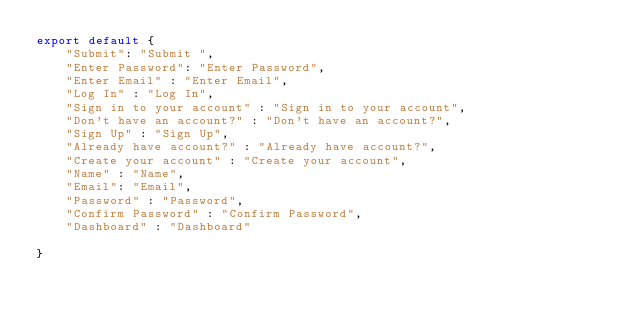Convert code to text. <code><loc_0><loc_0><loc_500><loc_500><_JavaScript_>export default {
    "Submit": "Submit ",
    "Enter Password": "Enter Password",
    "Enter Email" : "Enter Email",
    "Log In" : "Log In",
    "Sign in to your account" : "Sign in to your account",
    "Don't have an account?" : "Don't have an account?",
    "Sign Up" : "Sign Up",
    "Already have account?" : "Already have account?",
    "Create your account" : "Create your account",
    "Name" : "Name",
    "Email": "Email",
    "Password" : "Password",
    "Confirm Password" : "Confirm Password",
    "Dashboard" : "Dashboard"

}
</code> 